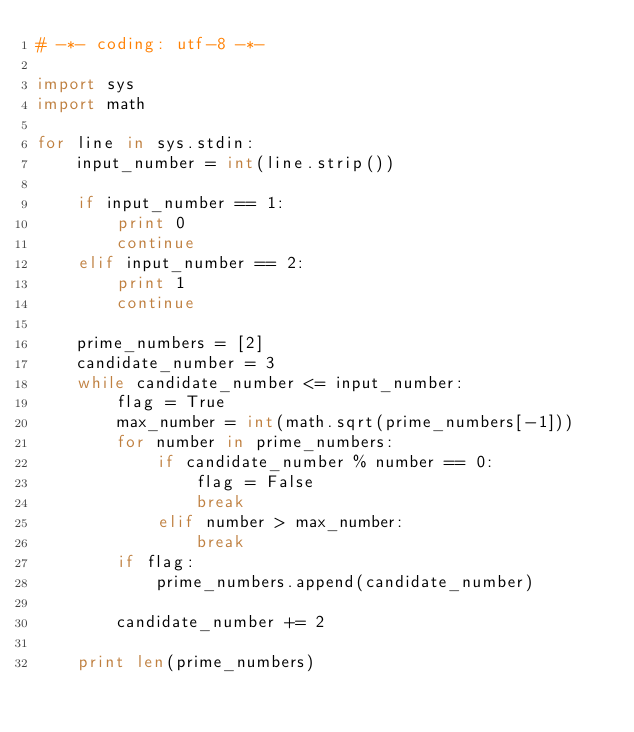<code> <loc_0><loc_0><loc_500><loc_500><_Python_># -*- coding: utf-8 -*-

import sys
import math

for line in sys.stdin:
    input_number = int(line.strip())

    if input_number == 1:
        print 0
        continue
    elif input_number == 2:
        print 1
        continue

    prime_numbers = [2]
    candidate_number = 3
    while candidate_number <= input_number:
        flag = True
        max_number = int(math.sqrt(prime_numbers[-1]))
        for number in prime_numbers:
            if candidate_number % number == 0:
                flag = False
                break
            elif number > max_number:
                break
        if flag:
            prime_numbers.append(candidate_number)

        candidate_number += 2

    print len(prime_numbers)</code> 